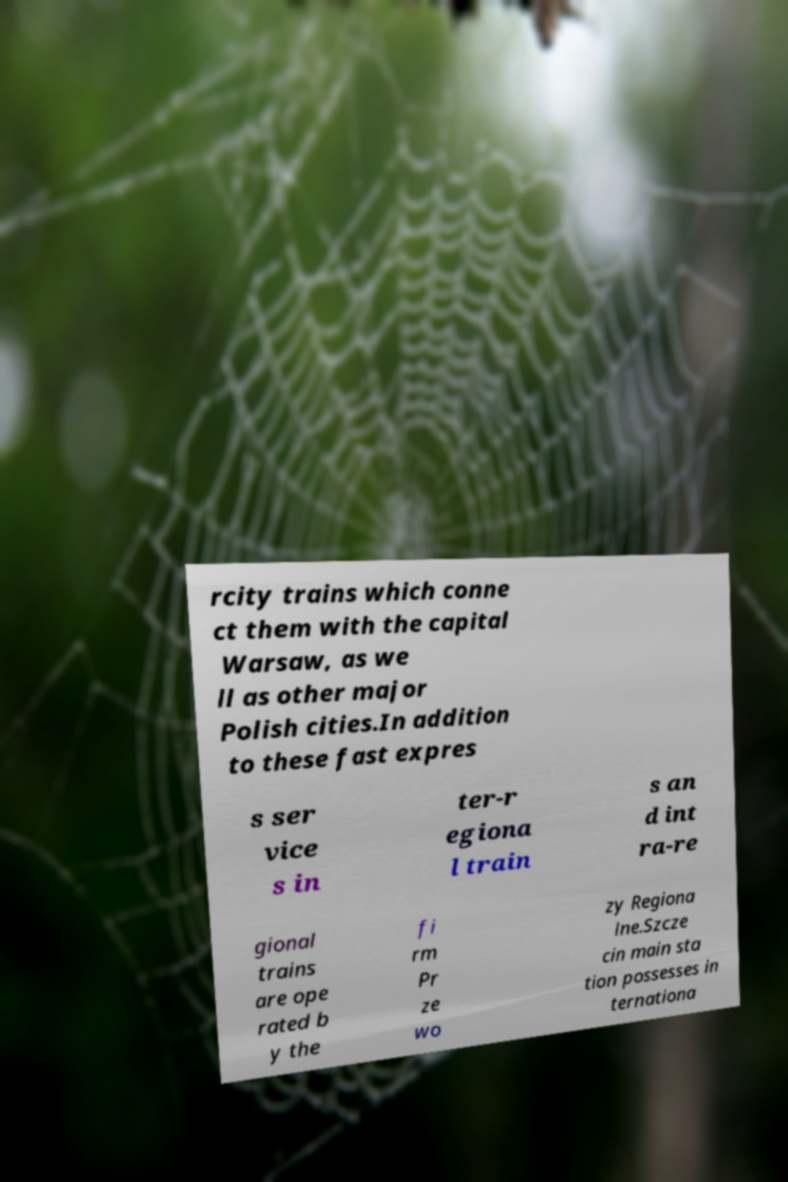Could you extract and type out the text from this image? rcity trains which conne ct them with the capital Warsaw, as we ll as other major Polish cities.In addition to these fast expres s ser vice s in ter-r egiona l train s an d int ra-re gional trains are ope rated b y the fi rm Pr ze wo zy Regiona lne.Szcze cin main sta tion possesses in ternationa 